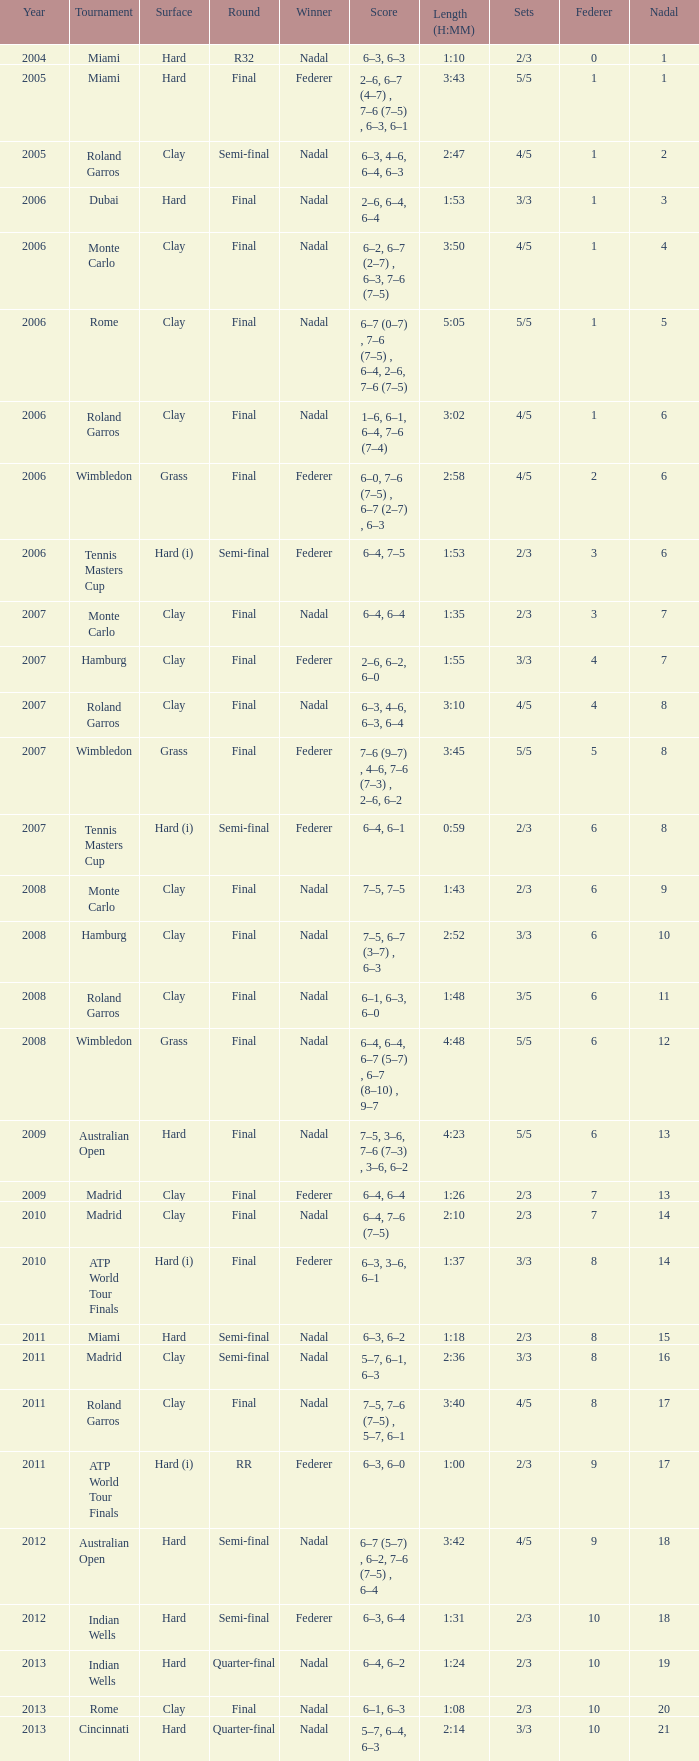In which tournament did nadal secure a win and accumulate 16 nadals? Madrid. 